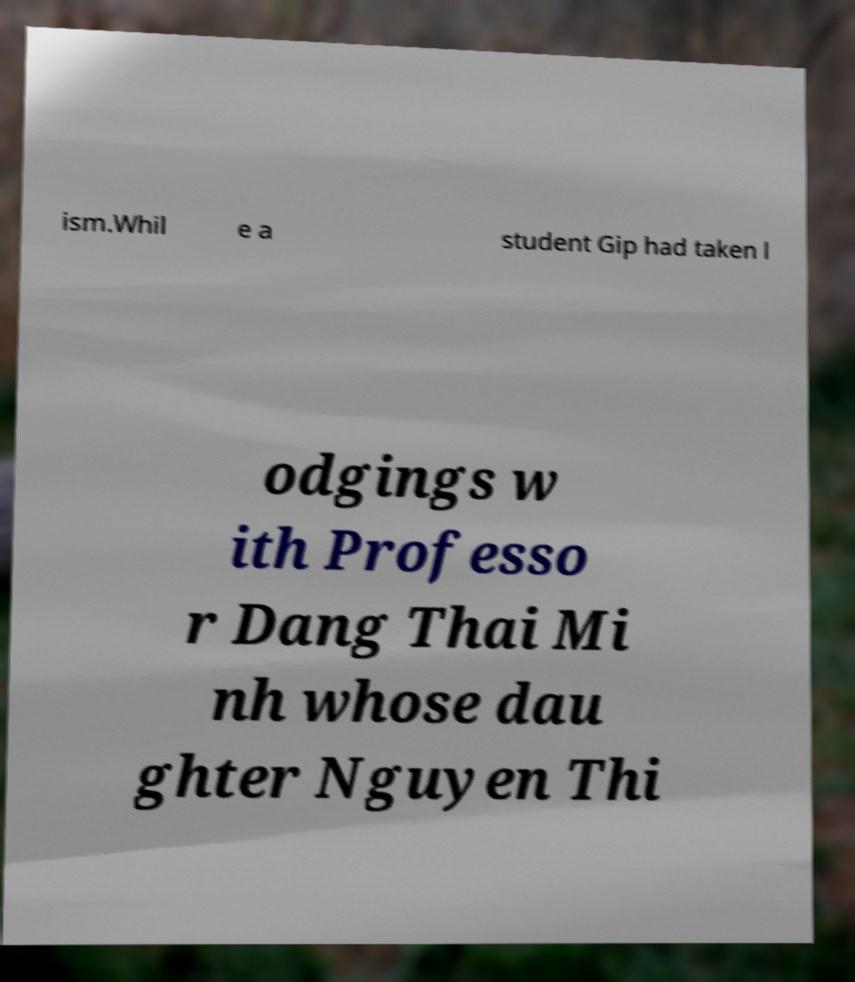I need the written content from this picture converted into text. Can you do that? ism.Whil e a student Gip had taken l odgings w ith Professo r Dang Thai Mi nh whose dau ghter Nguyen Thi 